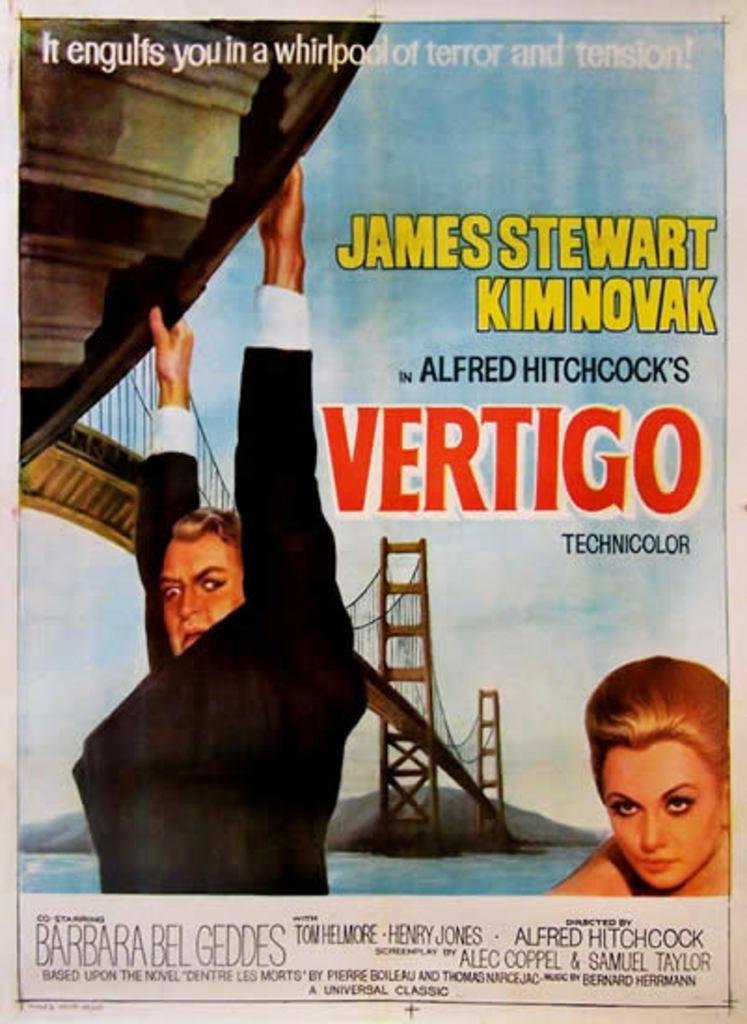<image>
Present a compact description of the photo's key features. A movie poster advertises the movie Vertigo by showing a man hanging off a bridge. 